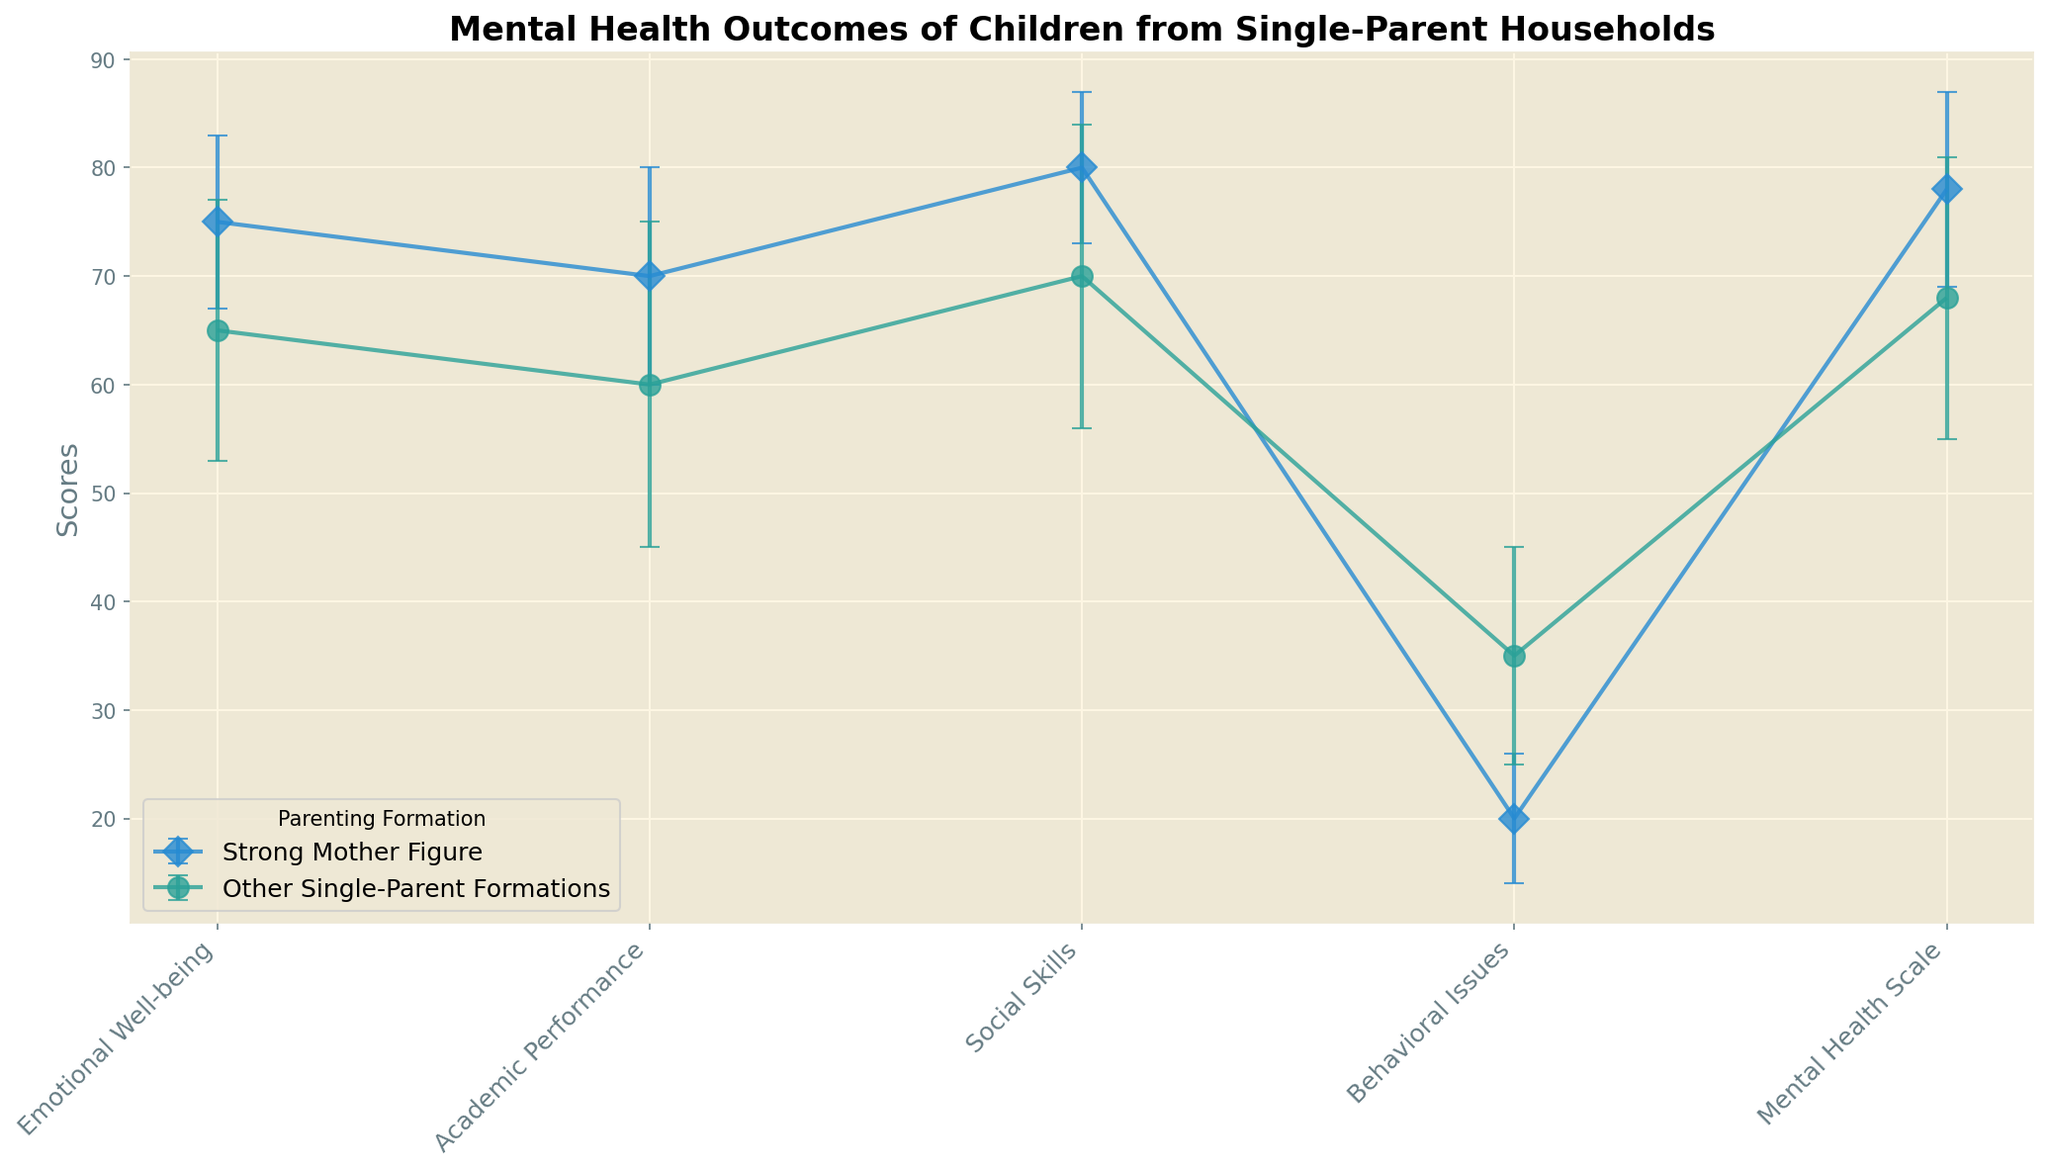What is the average mean score for Emotional Well-being across both single-parent formations? First, find the mean score for the Emotional Well-being outcome for both formations. For Strong Mother Figure, it is 75, and for Other Single-Parent Formations, it is 65. Add these two means (75 + 65 = 140) and then divide by the number of formations (2) to get the average mean score: 140 / 2 = 70.
Answer: 70 Which single-parent formation has the higher score for Academic Performance? Compare the mean scores for Academic Performance between the two formations. Strong Mother Figure has a mean of 70, while Other Single-Parent Formations have a mean of 60. Since 70 is greater than 60, Strong Mother Figure has the higher score for Academic Performance.
Answer: Strong Mother Figure By how much do Social Skills differ between Strong Mother Figure households and Other Single-Parent Formations? Look at the mean scores for Social Skills in each formation. For Strong Mother Figure, it is 80, and for Other Single-Parent Formations, it is 70. Subtract the lower mean from the higher mean (80 - 70) to find the difference: 10.
Answer: 10 Which outcome shows the greatest individual variation within Strong Mother Figure households? The variation is represented by the standard deviation. Compare the standard deviations for each outcome within the Strong Mother Figure formation: Emotional Well-being (8), Academic Performance (10), Social Skills (7), Behavioral Issues (6), Mental Health Scale (9). The highest standard deviation is 10 for Academic Performance.
Answer: Academic Performance Are the Behavioral Issues scores higher or lower in Strong Mother Figure households compared to Other Single-Parent Formations? Compare the mean scores for Behavioral Issues between the two formations. For Strong Mother Figure, it is 20, and for Other Single-Parent Formations, it is 35. Since 20 is less than 35, Behavioral Issues scores are lower in Strong Mother Figure households.
Answer: Lower What is the combined mental health scale score for both formations? Add the mean scores from both formations for the Mental Health Scale: 78 (Strong Mother Figure) + 68 (Other Single-Parent Formations) = 146.
Answer: 146 Which outcome has the smallest standard deviation across all formations? Compare the standard deviations for all outcomes across both formations: Emotional Well-being (8, 12), Academic Performance (10, 15), Social Skills (7, 14), Behavioral Issues (6, 10), Mental Health Scale (9, 13). The smallest standard deviation is 6 for Behavioral Issues in Strong Mother Figure households.
Answer: Behavioral Issues (Strong Mother Figure) How much higher or lower is the mean Emotional Well-being score for Strong Mother Figure households compared to Other Single-Parent Formations? Compare the mean Emotional Well-being scores: 75 (Strong Mother Figure) and 65 (Other Single-Parent Formations). Subtract the lower mean from the higher mean: 75 - 65 = 10. Since the result is positive, it is 10 points higher.
Answer: 10 points higher 